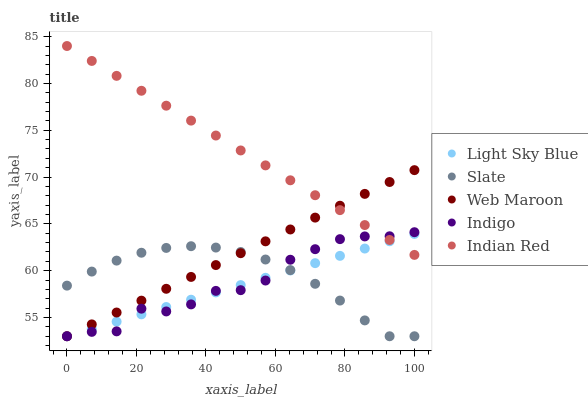Does Light Sky Blue have the minimum area under the curve?
Answer yes or no. Yes. Does Indian Red have the maximum area under the curve?
Answer yes or no. Yes. Does Slate have the minimum area under the curve?
Answer yes or no. No. Does Slate have the maximum area under the curve?
Answer yes or no. No. Is Web Maroon the smoothest?
Answer yes or no. Yes. Is Indigo the roughest?
Answer yes or no. Yes. Is Slate the smoothest?
Answer yes or no. No. Is Slate the roughest?
Answer yes or no. No. Does Indigo have the lowest value?
Answer yes or no. Yes. Does Indian Red have the lowest value?
Answer yes or no. No. Does Indian Red have the highest value?
Answer yes or no. Yes. Does Light Sky Blue have the highest value?
Answer yes or no. No. Is Slate less than Indian Red?
Answer yes or no. Yes. Is Indian Red greater than Slate?
Answer yes or no. Yes. Does Indigo intersect Slate?
Answer yes or no. Yes. Is Indigo less than Slate?
Answer yes or no. No. Is Indigo greater than Slate?
Answer yes or no. No. Does Slate intersect Indian Red?
Answer yes or no. No. 